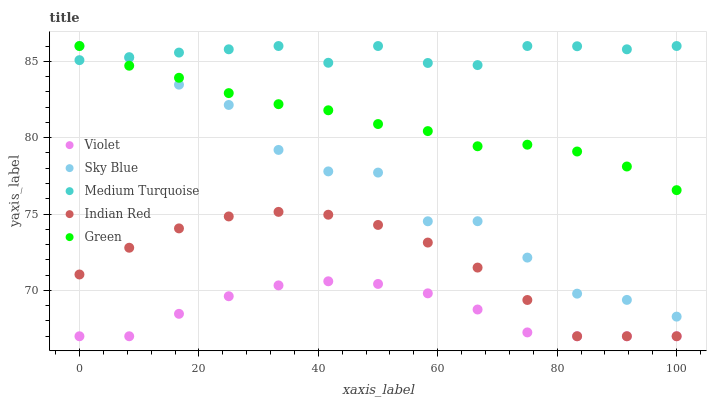Does Violet have the minimum area under the curve?
Answer yes or no. Yes. Does Medium Turquoise have the maximum area under the curve?
Answer yes or no. Yes. Does Green have the minimum area under the curve?
Answer yes or no. No. Does Green have the maximum area under the curve?
Answer yes or no. No. Is Green the smoothest?
Answer yes or no. Yes. Is Sky Blue the roughest?
Answer yes or no. Yes. Is Indian Red the smoothest?
Answer yes or no. No. Is Indian Red the roughest?
Answer yes or no. No. Does Indian Red have the lowest value?
Answer yes or no. Yes. Does Green have the lowest value?
Answer yes or no. No. Does Medium Turquoise have the highest value?
Answer yes or no. Yes. Does Indian Red have the highest value?
Answer yes or no. No. Is Indian Red less than Sky Blue?
Answer yes or no. Yes. Is Green greater than Indian Red?
Answer yes or no. Yes. Does Sky Blue intersect Medium Turquoise?
Answer yes or no. Yes. Is Sky Blue less than Medium Turquoise?
Answer yes or no. No. Is Sky Blue greater than Medium Turquoise?
Answer yes or no. No. Does Indian Red intersect Sky Blue?
Answer yes or no. No. 